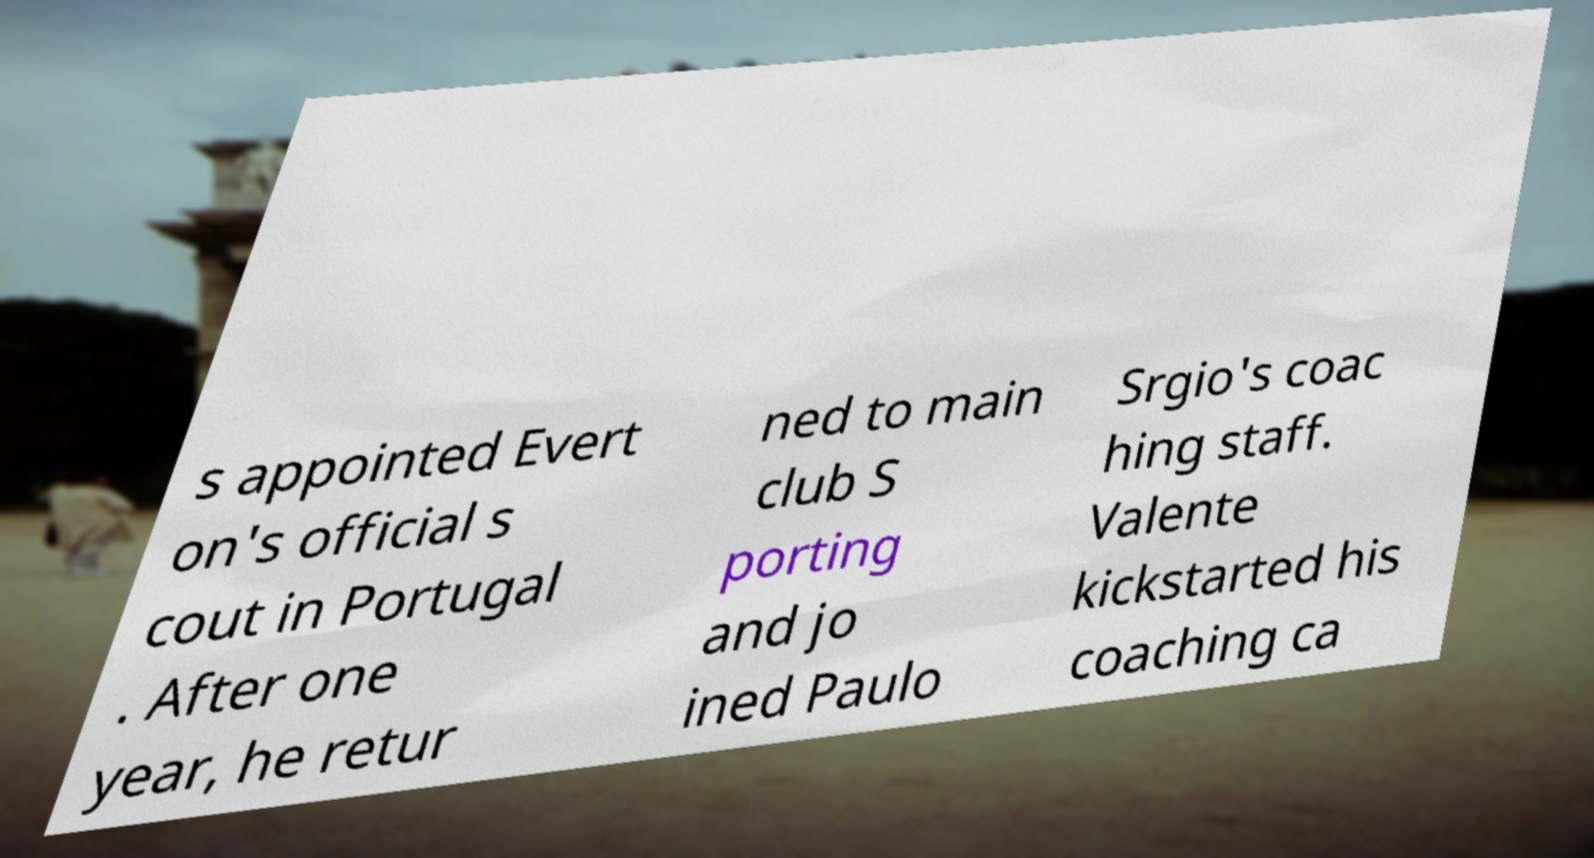Could you extract and type out the text from this image? s appointed Evert on's official s cout in Portugal . After one year, he retur ned to main club S porting and jo ined Paulo Srgio's coac hing staff. Valente kickstarted his coaching ca 